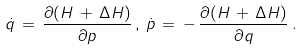Convert formula to latex. <formula><loc_0><loc_0><loc_500><loc_500>\dot { q } \, = \, \frac { \partial ( H \, + \, \Delta H ) } { \partial p } \, , \, \dot { p } \, = \, - \, \frac { \partial ( H \, + \, \Delta H ) } { \partial q } \, .</formula> 